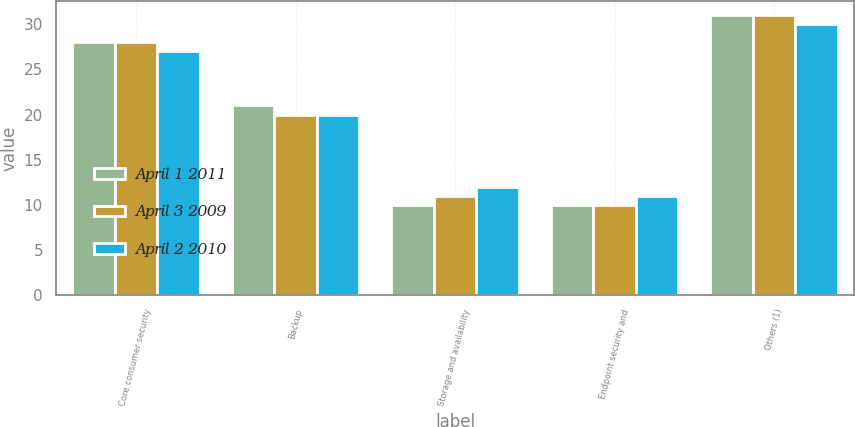<chart> <loc_0><loc_0><loc_500><loc_500><stacked_bar_chart><ecel><fcel>Core consumer security<fcel>Backup<fcel>Storage and availability<fcel>Endpoint security and<fcel>Others (1)<nl><fcel>April 1 2011<fcel>28<fcel>21<fcel>10<fcel>10<fcel>31<nl><fcel>April 3 2009<fcel>28<fcel>20<fcel>11<fcel>10<fcel>31<nl><fcel>April 2 2010<fcel>27<fcel>20<fcel>12<fcel>11<fcel>30<nl></chart> 